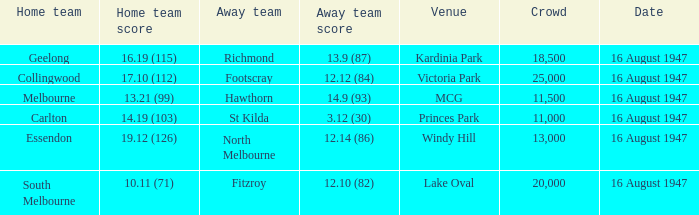What venue had footscray play at it? Victoria Park. 